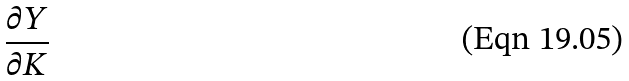<formula> <loc_0><loc_0><loc_500><loc_500>\frac { \partial Y } { \partial K }</formula> 